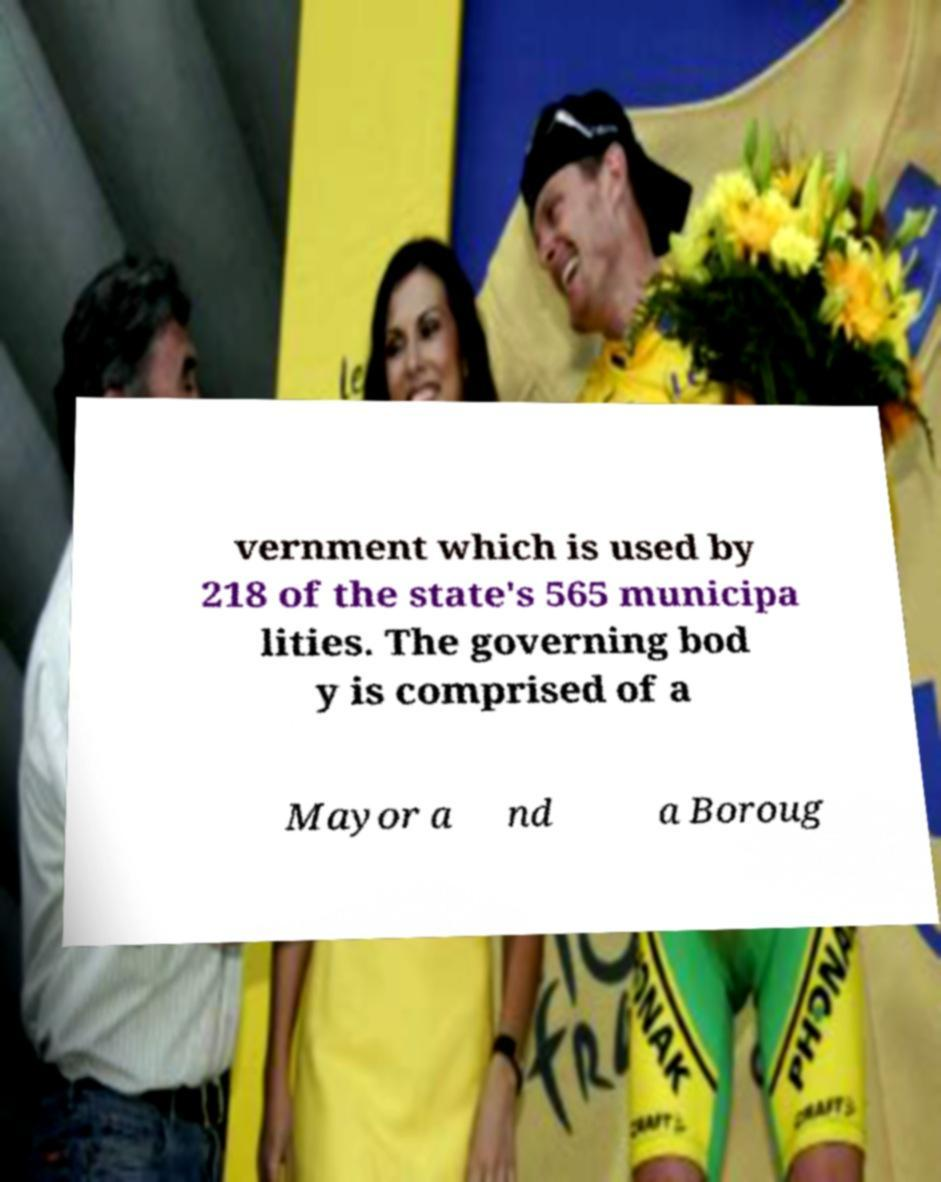Can you read and provide the text displayed in the image?This photo seems to have some interesting text. Can you extract and type it out for me? vernment which is used by 218 of the state's 565 municipa lities. The governing bod y is comprised of a Mayor a nd a Boroug 